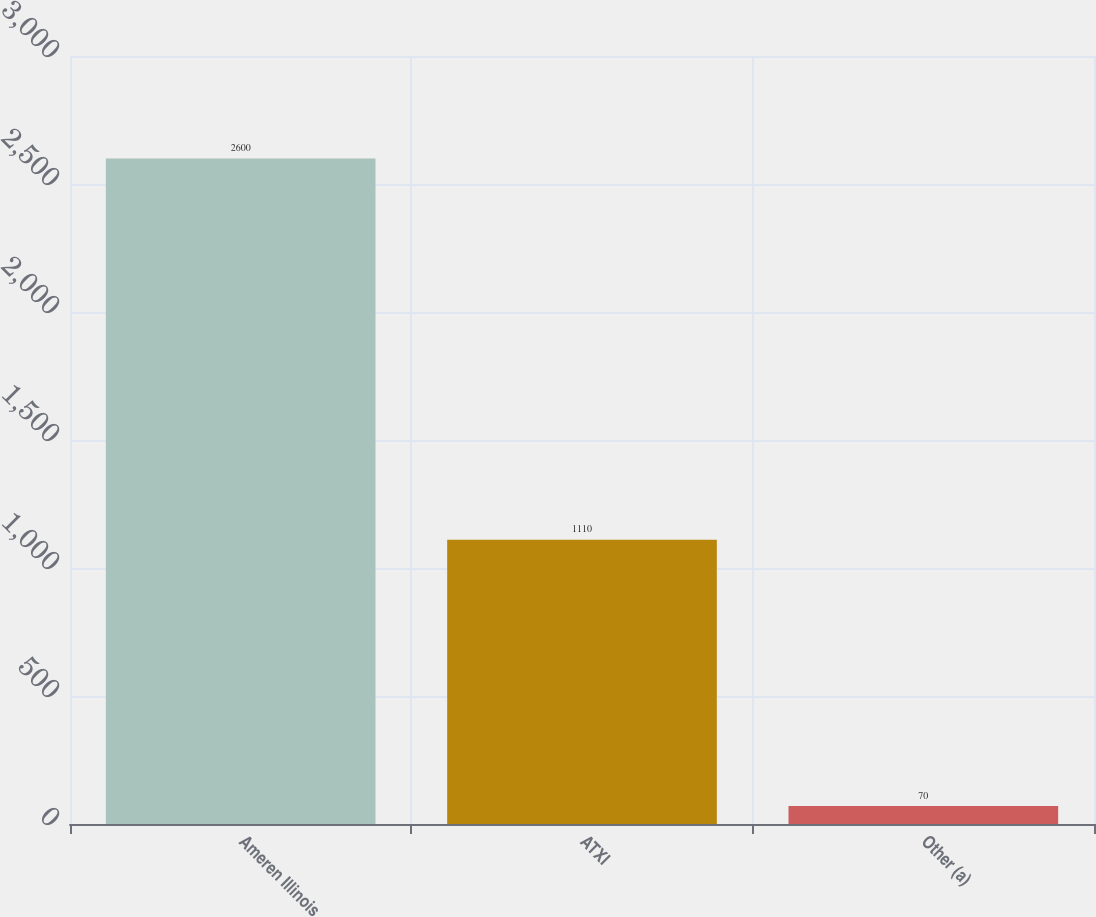Convert chart to OTSL. <chart><loc_0><loc_0><loc_500><loc_500><bar_chart><fcel>Ameren Illinois<fcel>ATXI<fcel>Other (a)<nl><fcel>2600<fcel>1110<fcel>70<nl></chart> 